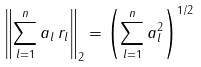Convert formula to latex. <formula><loc_0><loc_0><loc_500><loc_500>\left \| \sum _ { l = 1 } ^ { n } a _ { l } \, r _ { l } \right \| _ { 2 } = \left ( \sum _ { l = 1 } ^ { n } a _ { l } ^ { 2 } \right ) ^ { 1 / 2 }</formula> 